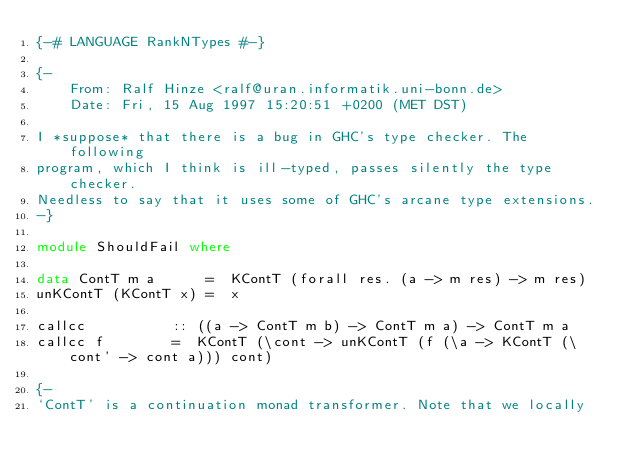<code> <loc_0><loc_0><loc_500><loc_500><_Haskell_>{-# LANGUAGE RankNTypes #-}

{- 
	From: Ralf Hinze <ralf@uran.informatik.uni-bonn.de>
	Date: Fri, 15 Aug 1997 15:20:51 +0200 (MET DST)

I *suppose* that there is a bug in GHC's type checker. The following
program, which I think is ill-typed, passes silently the type checker.
Needless to say that it uses some of GHC's arcane type extensions.
-}

module ShouldFail where

data ContT m a		=  KContT (forall res. (a -> m res) -> m res)
unKContT (KContT x)	=  x

callcc			:: ((a -> ContT m b) -> ContT m a) -> ContT m a
callcc f		=  KContT (\cont -> unKContT (f (\a -> KContT (\cont' -> cont a))) cont)

{-
`ContT' is a continuation monad transformer. Note that we locally</code> 